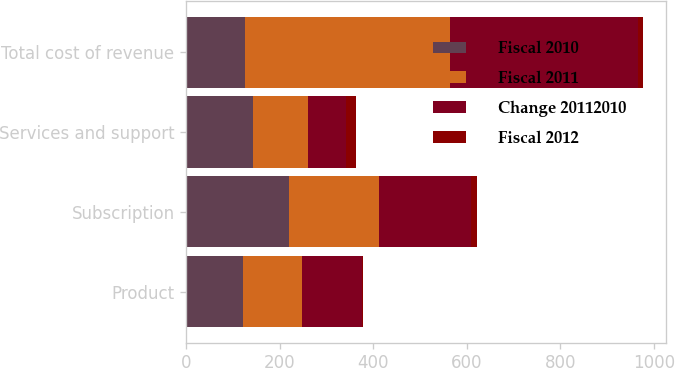Convert chart to OTSL. <chart><loc_0><loc_0><loc_500><loc_500><stacked_bar_chart><ecel><fcel>Product<fcel>Subscription<fcel>Services and support<fcel>Total cost of revenue<nl><fcel>Fiscal 2010<fcel>121.7<fcel>219.1<fcel>143<fcel>125.7<nl><fcel>Fiscal 2011<fcel>125.7<fcel>194<fcel>118.2<fcel>437.9<nl><fcel>Change 20112010<fcel>127.5<fcel>195.6<fcel>80.4<fcel>403.5<nl><fcel>Fiscal 2012<fcel>3<fcel>13<fcel>21<fcel>10<nl></chart> 